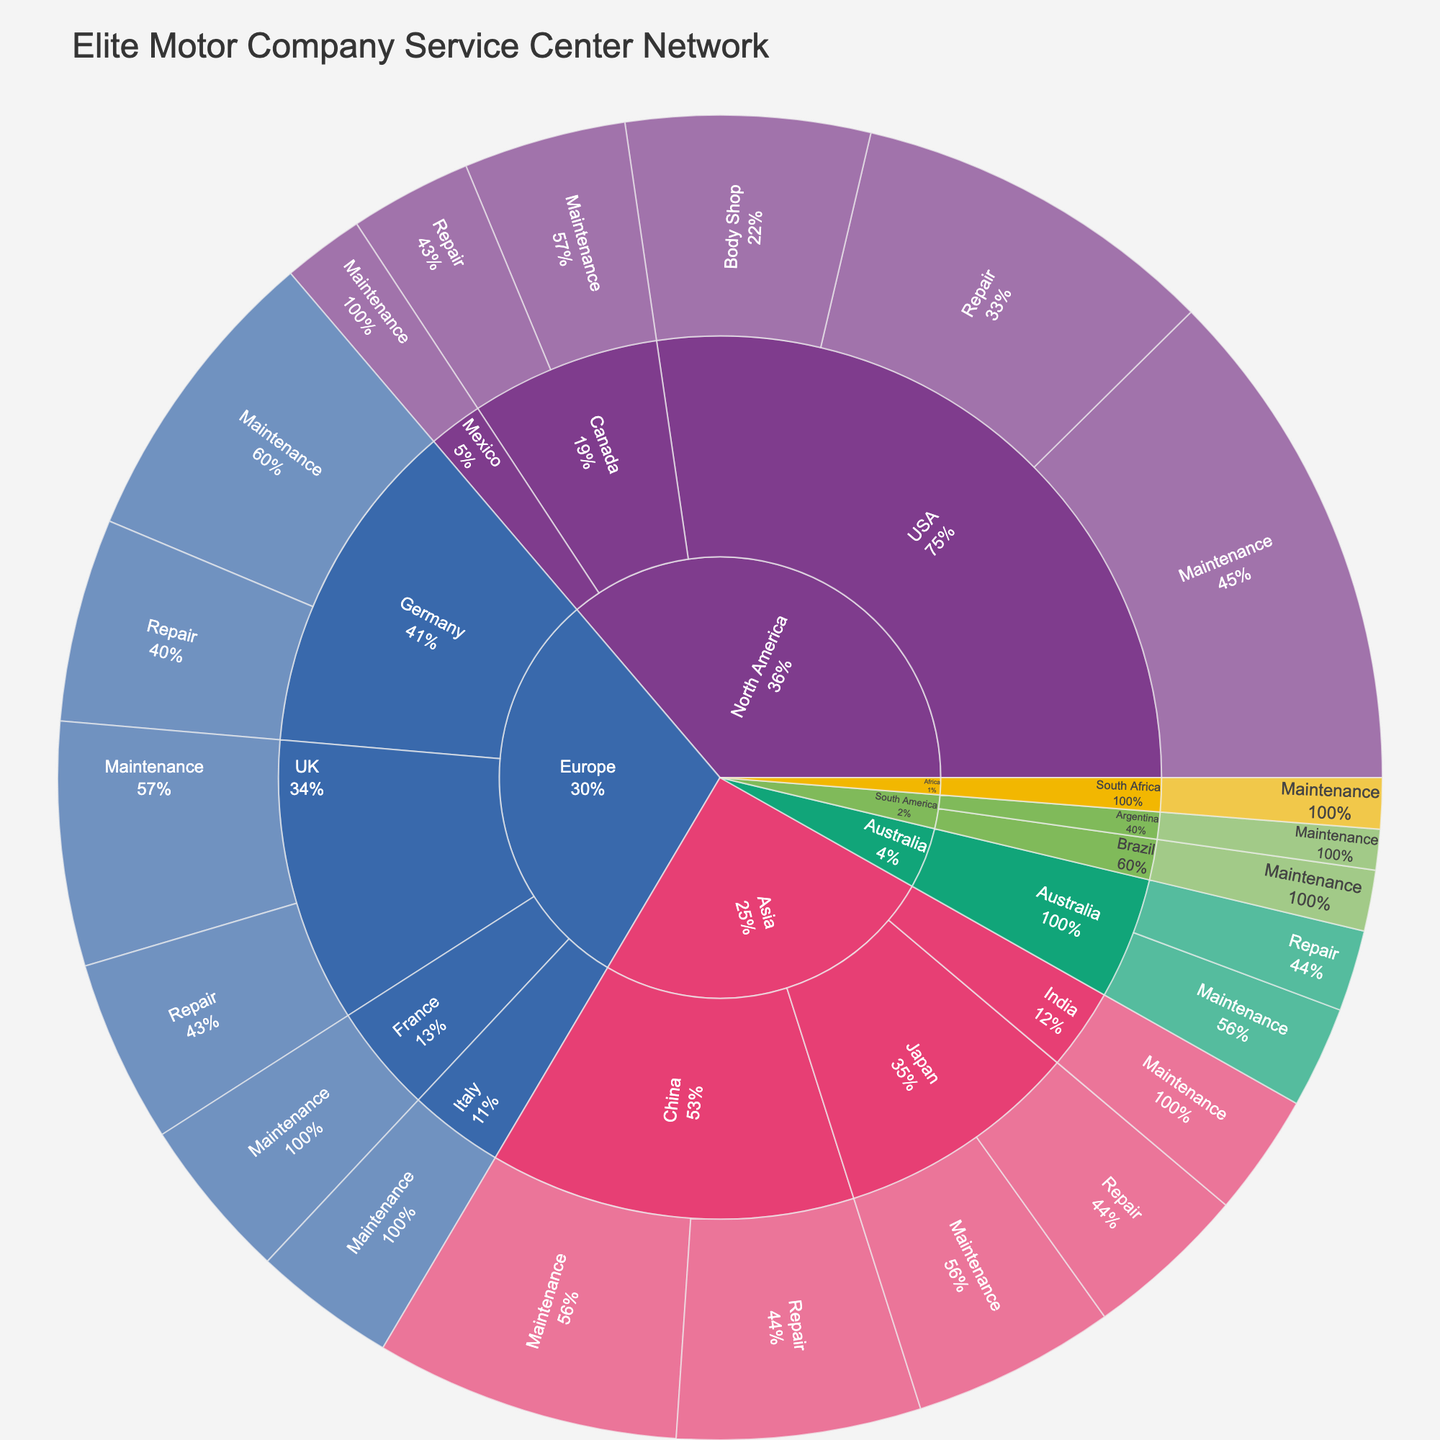How many service centers offer Maintenance services in the USA? From the sunburst plot, follow the path from North America → USA → Maintenance and observe the value associated with it.
Answer: 250 Which country in North America has the least number of Repair service centers, and what is the value? Within North America, inspect the Repair values for USA, Canada, and Mexico. The smallest value among these will identify the country with the least number.
Answer: Canada, 60 What is the total number of service centers in Europe? Look at each country within Europe (Germany, UK, France, Italy) and sum all their service types' values.
Answer: 610 Compare the number of Repair service centers between Japan and China. Which one has more, and by how much? Identify the Repair values for both Japan and China from the sunburst plot, then subtract Japan's value from China's value.
Answer: China by 40 What percentage of North America's total service centers are located in Canada? Calculate the total number of service centers in North America, then divide Canada's total number by this value, and multiply by 100 to get the percentage.
Answer: 22% Which continent has the highest number of Maintenance service centers? Compare the Maintenance values across all continents and identify the largest value.
Answer: North America How many service centers in total does Elite Motor Company have across all continents? Add up the values for all service types across all continents in the plot to get the total number of service centers.
Answer: 1725 In which continent does the country with the least number of total service centers reside, and what is that country? Examine the total values for individual countries and identify the smallest one, then determine its continent.
Answer: Africa, South Africa What is the average number of Maintenance service centers among the countries in Europe? Add up all Maintenance values in European countries and divide by the number of those countries (Germany, UK, France, Italy).
Answer: 105 Which country has the highest individual value for Repair services, and what is the value? Look for the highest Repair value across all countries within the sunburst plot.
Answer: USA, 180 